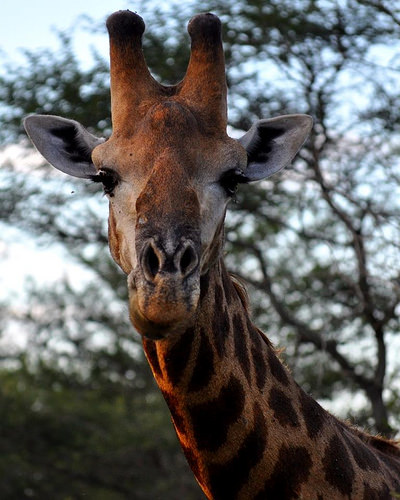<image>
Is there a giraffe in the trees? No. The giraffe is not contained within the trees. These objects have a different spatial relationship. 